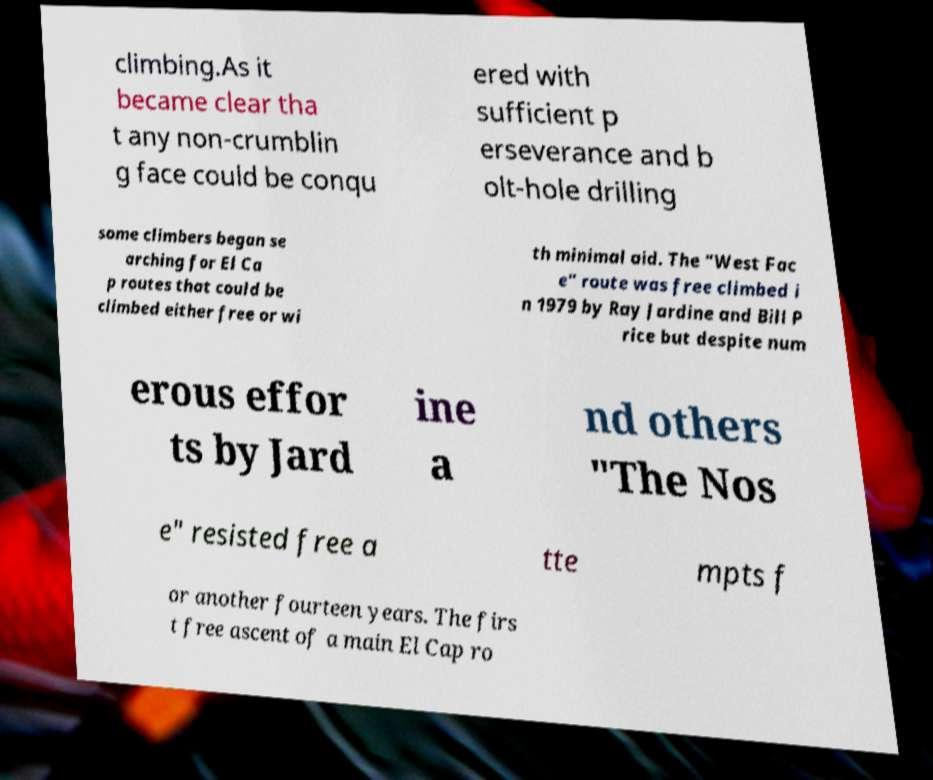Could you assist in decoding the text presented in this image and type it out clearly? climbing.As it became clear tha t any non-crumblin g face could be conqu ered with sufficient p erseverance and b olt-hole drilling some climbers began se arching for El Ca p routes that could be climbed either free or wi th minimal aid. The "West Fac e" route was free climbed i n 1979 by Ray Jardine and Bill P rice but despite num erous effor ts by Jard ine a nd others "The Nos e" resisted free a tte mpts f or another fourteen years. The firs t free ascent of a main El Cap ro 